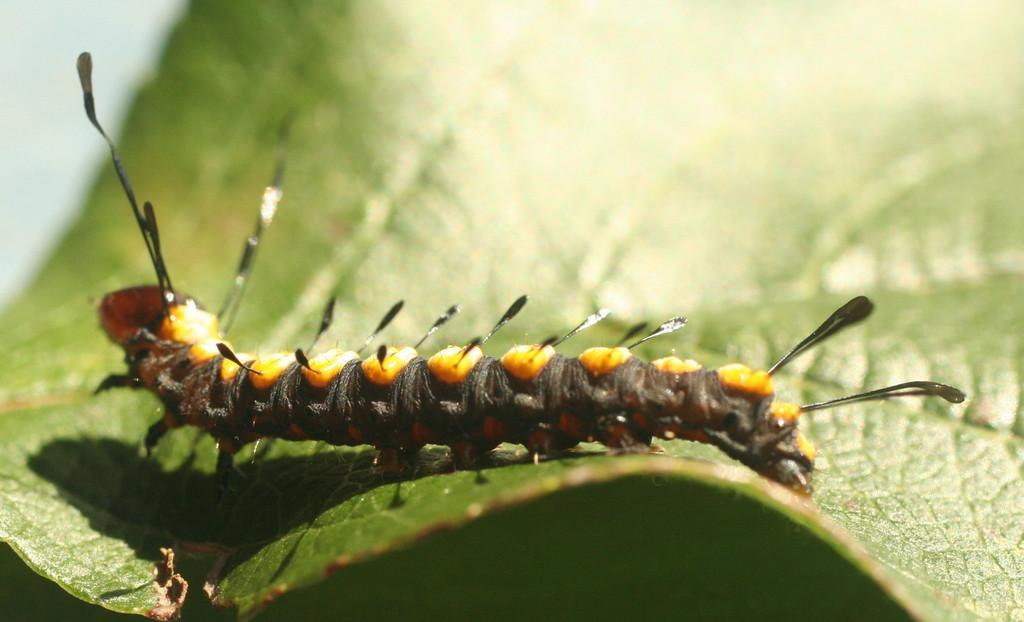What is the main subject of the image? There is an insect on a leaf in the image. Can you describe the background of the image? The background of the image is blurred. What type of space exploration equipment can be seen in the image? There is no space exploration equipment present in the image; it features an insect on a leaf with a blurred background. Can you describe the bun that the insect is holding in the image? There is no bun present in the image; it only features an insect on a leaf with a blurred background. 